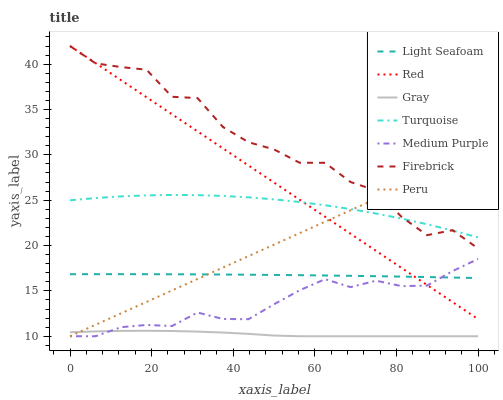Does Gray have the minimum area under the curve?
Answer yes or no. Yes. Does Firebrick have the maximum area under the curve?
Answer yes or no. Yes. Does Turquoise have the minimum area under the curve?
Answer yes or no. No. Does Turquoise have the maximum area under the curve?
Answer yes or no. No. Is Red the smoothest?
Answer yes or no. Yes. Is Firebrick the roughest?
Answer yes or no. Yes. Is Turquoise the smoothest?
Answer yes or no. No. Is Turquoise the roughest?
Answer yes or no. No. Does Gray have the lowest value?
Answer yes or no. Yes. Does Firebrick have the lowest value?
Answer yes or no. No. Does Red have the highest value?
Answer yes or no. Yes. Does Turquoise have the highest value?
Answer yes or no. No. Is Medium Purple less than Firebrick?
Answer yes or no. Yes. Is Turquoise greater than Gray?
Answer yes or no. Yes. Does Turquoise intersect Peru?
Answer yes or no. Yes. Is Turquoise less than Peru?
Answer yes or no. No. Is Turquoise greater than Peru?
Answer yes or no. No. Does Medium Purple intersect Firebrick?
Answer yes or no. No. 